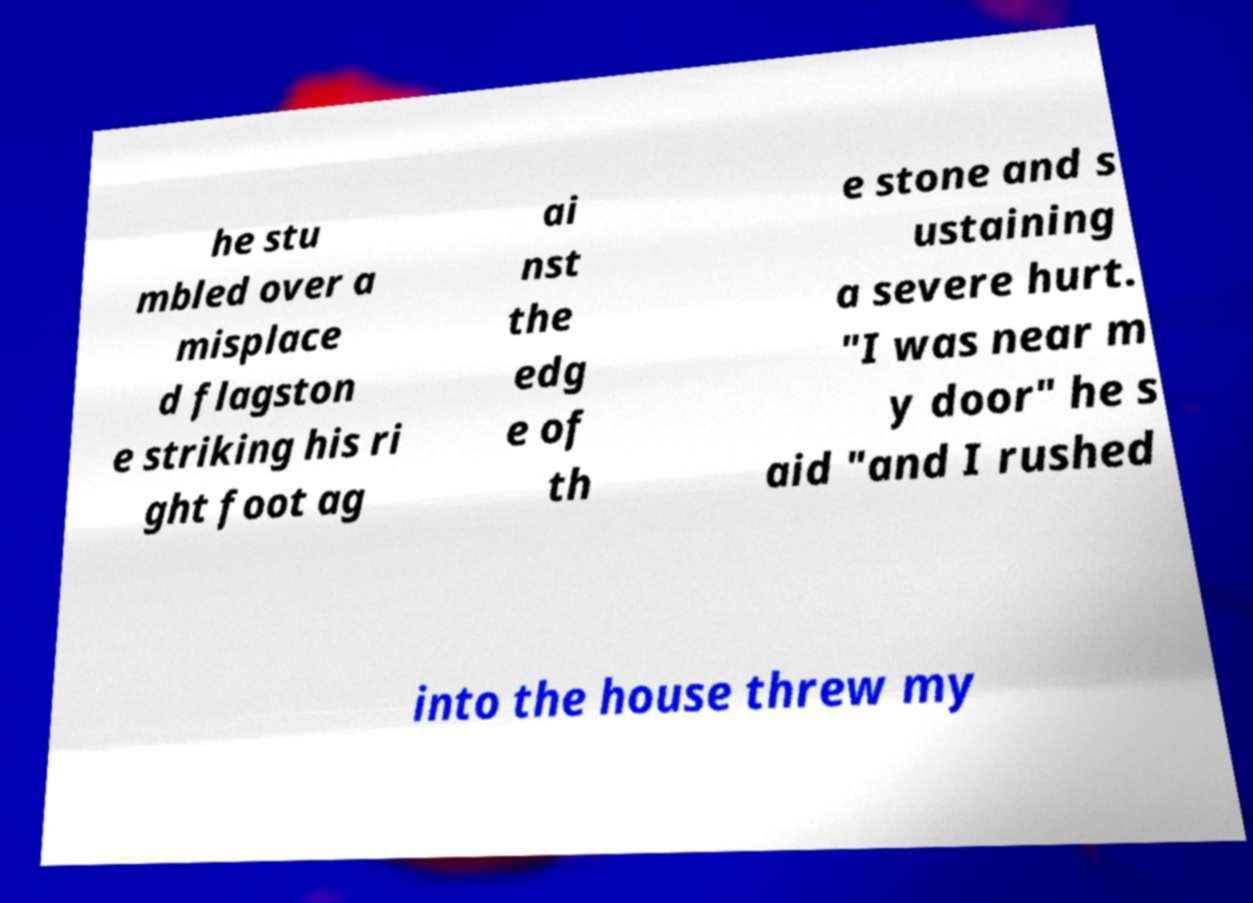What messages or text are displayed in this image? I need them in a readable, typed format. he stu mbled over a misplace d flagston e striking his ri ght foot ag ai nst the edg e of th e stone and s ustaining a severe hurt. "I was near m y door" he s aid "and I rushed into the house threw my 